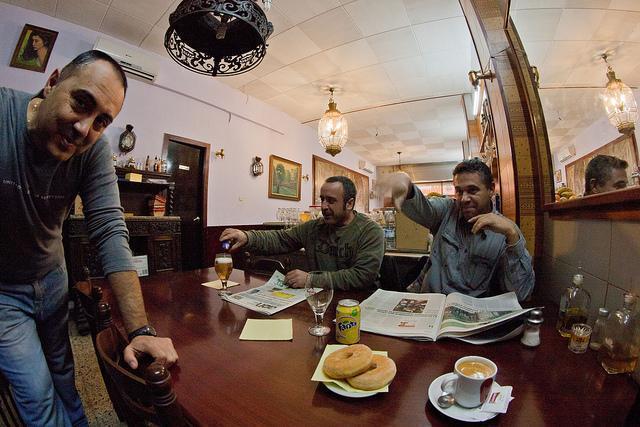How does the person in the image tell time?
Choose the correct response, then elucidate: 'Answer: answer
Rationale: rationale.'
Options: Wrist watch, wall clock, phone, microwave. Answer: wrist watch.
Rationale: This is evident by the object on his wrist. there may be a c or b nearby, but they're not shown. 